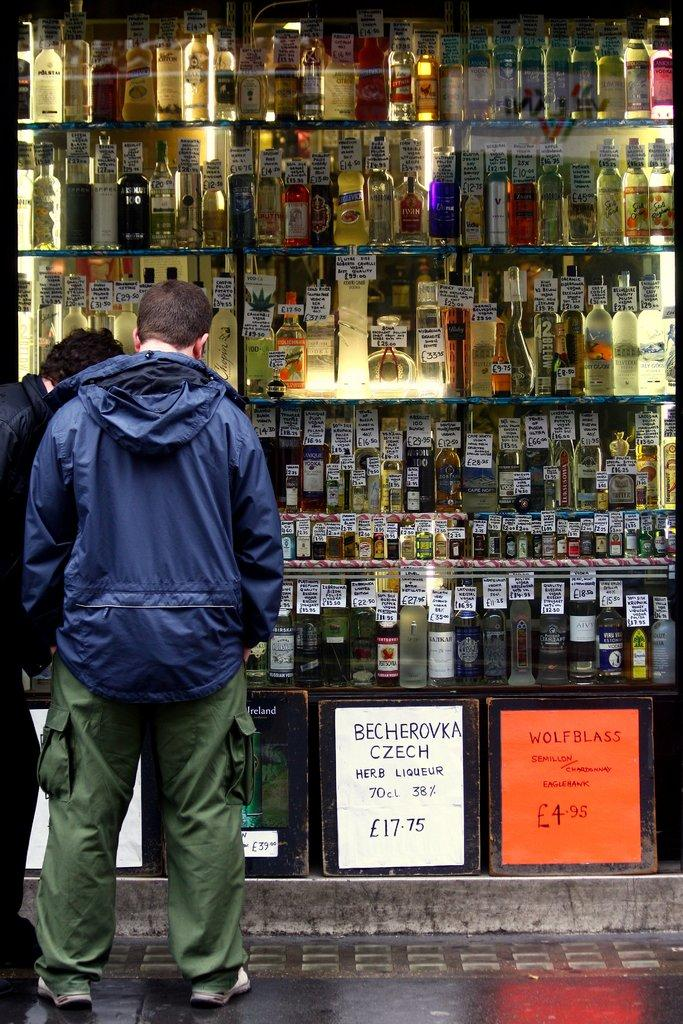<image>
Describe the image concisely. Two men looking inside an alcohol store saying "Wolf Blass" in the front. 